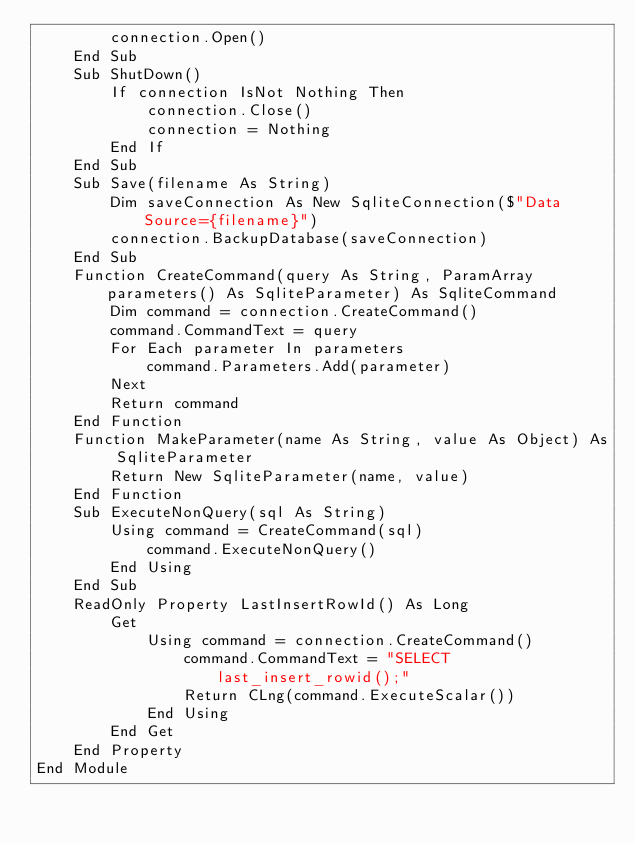<code> <loc_0><loc_0><loc_500><loc_500><_VisualBasic_>        connection.Open()
    End Sub
    Sub ShutDown()
        If connection IsNot Nothing Then
            connection.Close()
            connection = Nothing
        End If
    End Sub
    Sub Save(filename As String)
        Dim saveConnection As New SqliteConnection($"Data Source={filename}")
        connection.BackupDatabase(saveConnection)
    End Sub
    Function CreateCommand(query As String, ParamArray parameters() As SqliteParameter) As SqliteCommand
        Dim command = connection.CreateCommand()
        command.CommandText = query
        For Each parameter In parameters
            command.Parameters.Add(parameter)
        Next
        Return command
    End Function
    Function MakeParameter(name As String, value As Object) As SqliteParameter
        Return New SqliteParameter(name, value)
    End Function
    Sub ExecuteNonQuery(sql As String)
        Using command = CreateCommand(sql)
            command.ExecuteNonQuery()
        End Using
    End Sub
    ReadOnly Property LastInsertRowId() As Long
        Get
            Using command = connection.CreateCommand()
                command.CommandText = "SELECT last_insert_rowid();"
                Return CLng(command.ExecuteScalar())
            End Using
        End Get
    End Property
End Module
</code> 